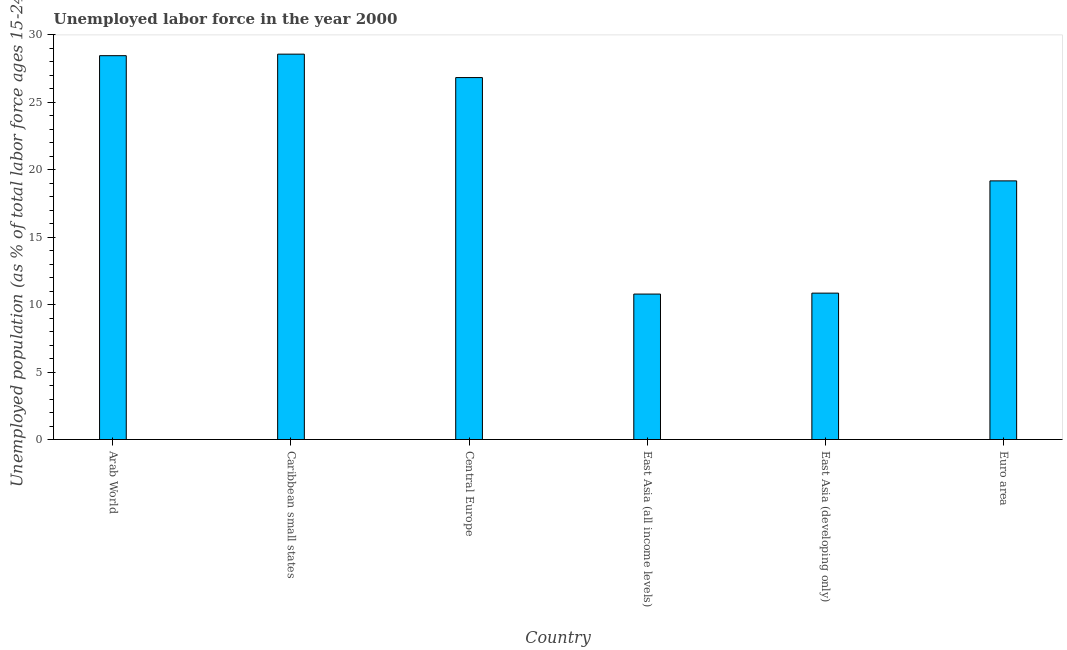Does the graph contain any zero values?
Your answer should be very brief. No. What is the title of the graph?
Your answer should be compact. Unemployed labor force in the year 2000. What is the label or title of the X-axis?
Offer a very short reply. Country. What is the label or title of the Y-axis?
Your answer should be very brief. Unemployed population (as % of total labor force ages 15-24). What is the total unemployed youth population in East Asia (developing only)?
Your response must be concise. 10.85. Across all countries, what is the maximum total unemployed youth population?
Offer a very short reply. 28.58. Across all countries, what is the minimum total unemployed youth population?
Provide a short and direct response. 10.79. In which country was the total unemployed youth population maximum?
Offer a very short reply. Caribbean small states. In which country was the total unemployed youth population minimum?
Your answer should be very brief. East Asia (all income levels). What is the sum of the total unemployed youth population?
Ensure brevity in your answer.  124.69. What is the difference between the total unemployed youth population in Central Europe and East Asia (all income levels)?
Offer a very short reply. 16.05. What is the average total unemployed youth population per country?
Your response must be concise. 20.78. What is the median total unemployed youth population?
Your answer should be compact. 23.01. What is the ratio of the total unemployed youth population in Arab World to that in East Asia (developing only)?
Offer a very short reply. 2.62. Is the difference between the total unemployed youth population in Arab World and East Asia (developing only) greater than the difference between any two countries?
Provide a short and direct response. No. What is the difference between the highest and the second highest total unemployed youth population?
Offer a terse response. 0.11. Is the sum of the total unemployed youth population in Caribbean small states and East Asia (all income levels) greater than the maximum total unemployed youth population across all countries?
Your response must be concise. Yes. What is the difference between the highest and the lowest total unemployed youth population?
Offer a very short reply. 17.79. How many bars are there?
Keep it short and to the point. 6. Are all the bars in the graph horizontal?
Give a very brief answer. No. What is the Unemployed population (as % of total labor force ages 15-24) of Arab World?
Provide a short and direct response. 28.46. What is the Unemployed population (as % of total labor force ages 15-24) of Caribbean small states?
Your answer should be compact. 28.58. What is the Unemployed population (as % of total labor force ages 15-24) of Central Europe?
Your answer should be very brief. 26.84. What is the Unemployed population (as % of total labor force ages 15-24) of East Asia (all income levels)?
Offer a very short reply. 10.79. What is the Unemployed population (as % of total labor force ages 15-24) of East Asia (developing only)?
Your response must be concise. 10.85. What is the Unemployed population (as % of total labor force ages 15-24) in Euro area?
Offer a terse response. 19.18. What is the difference between the Unemployed population (as % of total labor force ages 15-24) in Arab World and Caribbean small states?
Provide a short and direct response. -0.11. What is the difference between the Unemployed population (as % of total labor force ages 15-24) in Arab World and Central Europe?
Ensure brevity in your answer.  1.62. What is the difference between the Unemployed population (as % of total labor force ages 15-24) in Arab World and East Asia (all income levels)?
Your response must be concise. 17.68. What is the difference between the Unemployed population (as % of total labor force ages 15-24) in Arab World and East Asia (developing only)?
Your answer should be compact. 17.61. What is the difference between the Unemployed population (as % of total labor force ages 15-24) in Arab World and Euro area?
Offer a very short reply. 9.28. What is the difference between the Unemployed population (as % of total labor force ages 15-24) in Caribbean small states and Central Europe?
Give a very brief answer. 1.74. What is the difference between the Unemployed population (as % of total labor force ages 15-24) in Caribbean small states and East Asia (all income levels)?
Give a very brief answer. 17.79. What is the difference between the Unemployed population (as % of total labor force ages 15-24) in Caribbean small states and East Asia (developing only)?
Your answer should be compact. 17.72. What is the difference between the Unemployed population (as % of total labor force ages 15-24) in Caribbean small states and Euro area?
Provide a short and direct response. 9.4. What is the difference between the Unemployed population (as % of total labor force ages 15-24) in Central Europe and East Asia (all income levels)?
Provide a short and direct response. 16.05. What is the difference between the Unemployed population (as % of total labor force ages 15-24) in Central Europe and East Asia (developing only)?
Your answer should be very brief. 15.98. What is the difference between the Unemployed population (as % of total labor force ages 15-24) in Central Europe and Euro area?
Your answer should be very brief. 7.66. What is the difference between the Unemployed population (as % of total labor force ages 15-24) in East Asia (all income levels) and East Asia (developing only)?
Keep it short and to the point. -0.07. What is the difference between the Unemployed population (as % of total labor force ages 15-24) in East Asia (all income levels) and Euro area?
Give a very brief answer. -8.39. What is the difference between the Unemployed population (as % of total labor force ages 15-24) in East Asia (developing only) and Euro area?
Your answer should be compact. -8.32. What is the ratio of the Unemployed population (as % of total labor force ages 15-24) in Arab World to that in Caribbean small states?
Give a very brief answer. 1. What is the ratio of the Unemployed population (as % of total labor force ages 15-24) in Arab World to that in Central Europe?
Offer a very short reply. 1.06. What is the ratio of the Unemployed population (as % of total labor force ages 15-24) in Arab World to that in East Asia (all income levels)?
Keep it short and to the point. 2.64. What is the ratio of the Unemployed population (as % of total labor force ages 15-24) in Arab World to that in East Asia (developing only)?
Ensure brevity in your answer.  2.62. What is the ratio of the Unemployed population (as % of total labor force ages 15-24) in Arab World to that in Euro area?
Give a very brief answer. 1.48. What is the ratio of the Unemployed population (as % of total labor force ages 15-24) in Caribbean small states to that in Central Europe?
Offer a very short reply. 1.06. What is the ratio of the Unemployed population (as % of total labor force ages 15-24) in Caribbean small states to that in East Asia (all income levels)?
Provide a short and direct response. 2.65. What is the ratio of the Unemployed population (as % of total labor force ages 15-24) in Caribbean small states to that in East Asia (developing only)?
Your response must be concise. 2.63. What is the ratio of the Unemployed population (as % of total labor force ages 15-24) in Caribbean small states to that in Euro area?
Provide a succinct answer. 1.49. What is the ratio of the Unemployed population (as % of total labor force ages 15-24) in Central Europe to that in East Asia (all income levels)?
Keep it short and to the point. 2.49. What is the ratio of the Unemployed population (as % of total labor force ages 15-24) in Central Europe to that in East Asia (developing only)?
Provide a succinct answer. 2.47. What is the ratio of the Unemployed population (as % of total labor force ages 15-24) in Central Europe to that in Euro area?
Your response must be concise. 1.4. What is the ratio of the Unemployed population (as % of total labor force ages 15-24) in East Asia (all income levels) to that in Euro area?
Provide a short and direct response. 0.56. What is the ratio of the Unemployed population (as % of total labor force ages 15-24) in East Asia (developing only) to that in Euro area?
Keep it short and to the point. 0.57. 